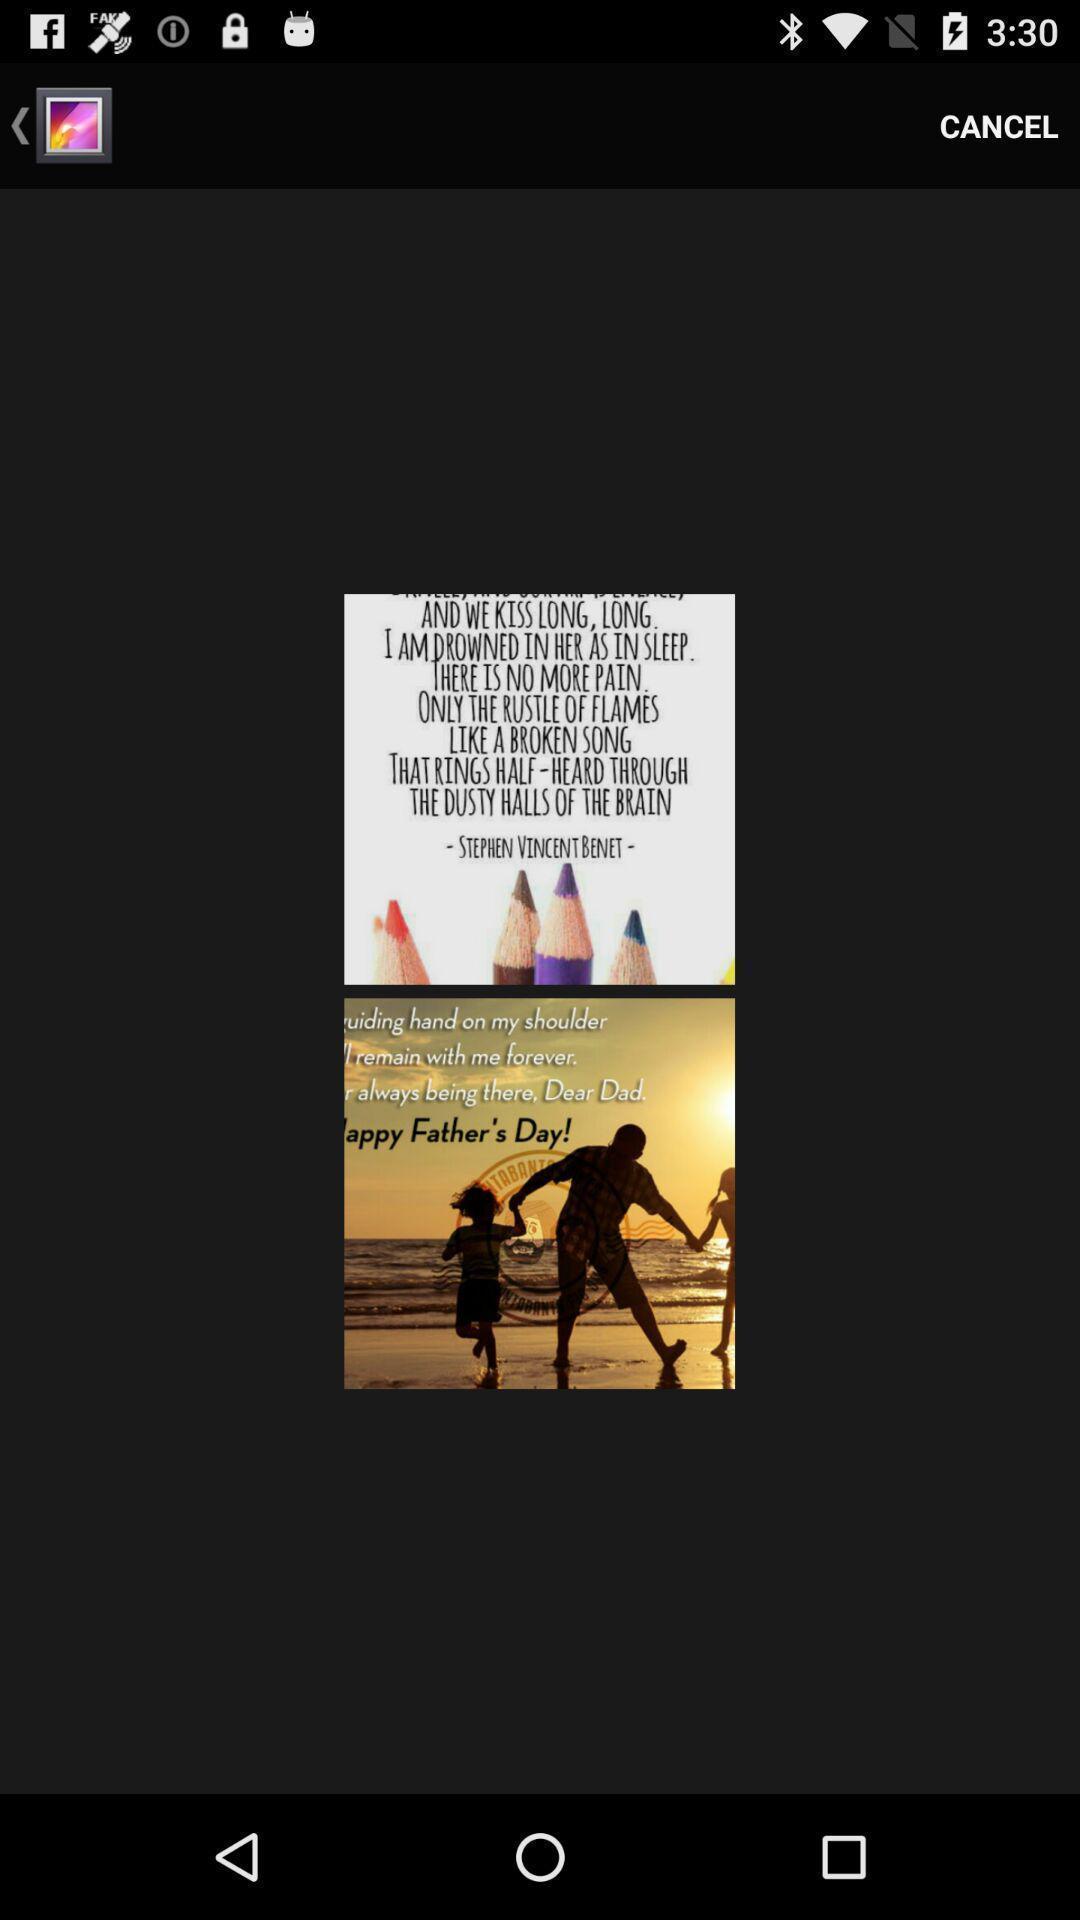Give me a summary of this screen capture. Screen displaying the image in a gallery. 